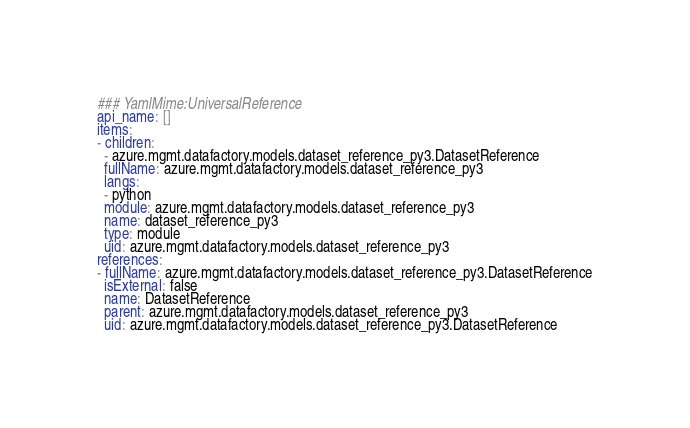Convert code to text. <code><loc_0><loc_0><loc_500><loc_500><_YAML_>### YamlMime:UniversalReference
api_name: []
items:
- children:
  - azure.mgmt.datafactory.models.dataset_reference_py3.DatasetReference
  fullName: azure.mgmt.datafactory.models.dataset_reference_py3
  langs:
  - python
  module: azure.mgmt.datafactory.models.dataset_reference_py3
  name: dataset_reference_py3
  type: module
  uid: azure.mgmt.datafactory.models.dataset_reference_py3
references:
- fullName: azure.mgmt.datafactory.models.dataset_reference_py3.DatasetReference
  isExternal: false
  name: DatasetReference
  parent: azure.mgmt.datafactory.models.dataset_reference_py3
  uid: azure.mgmt.datafactory.models.dataset_reference_py3.DatasetReference
</code> 